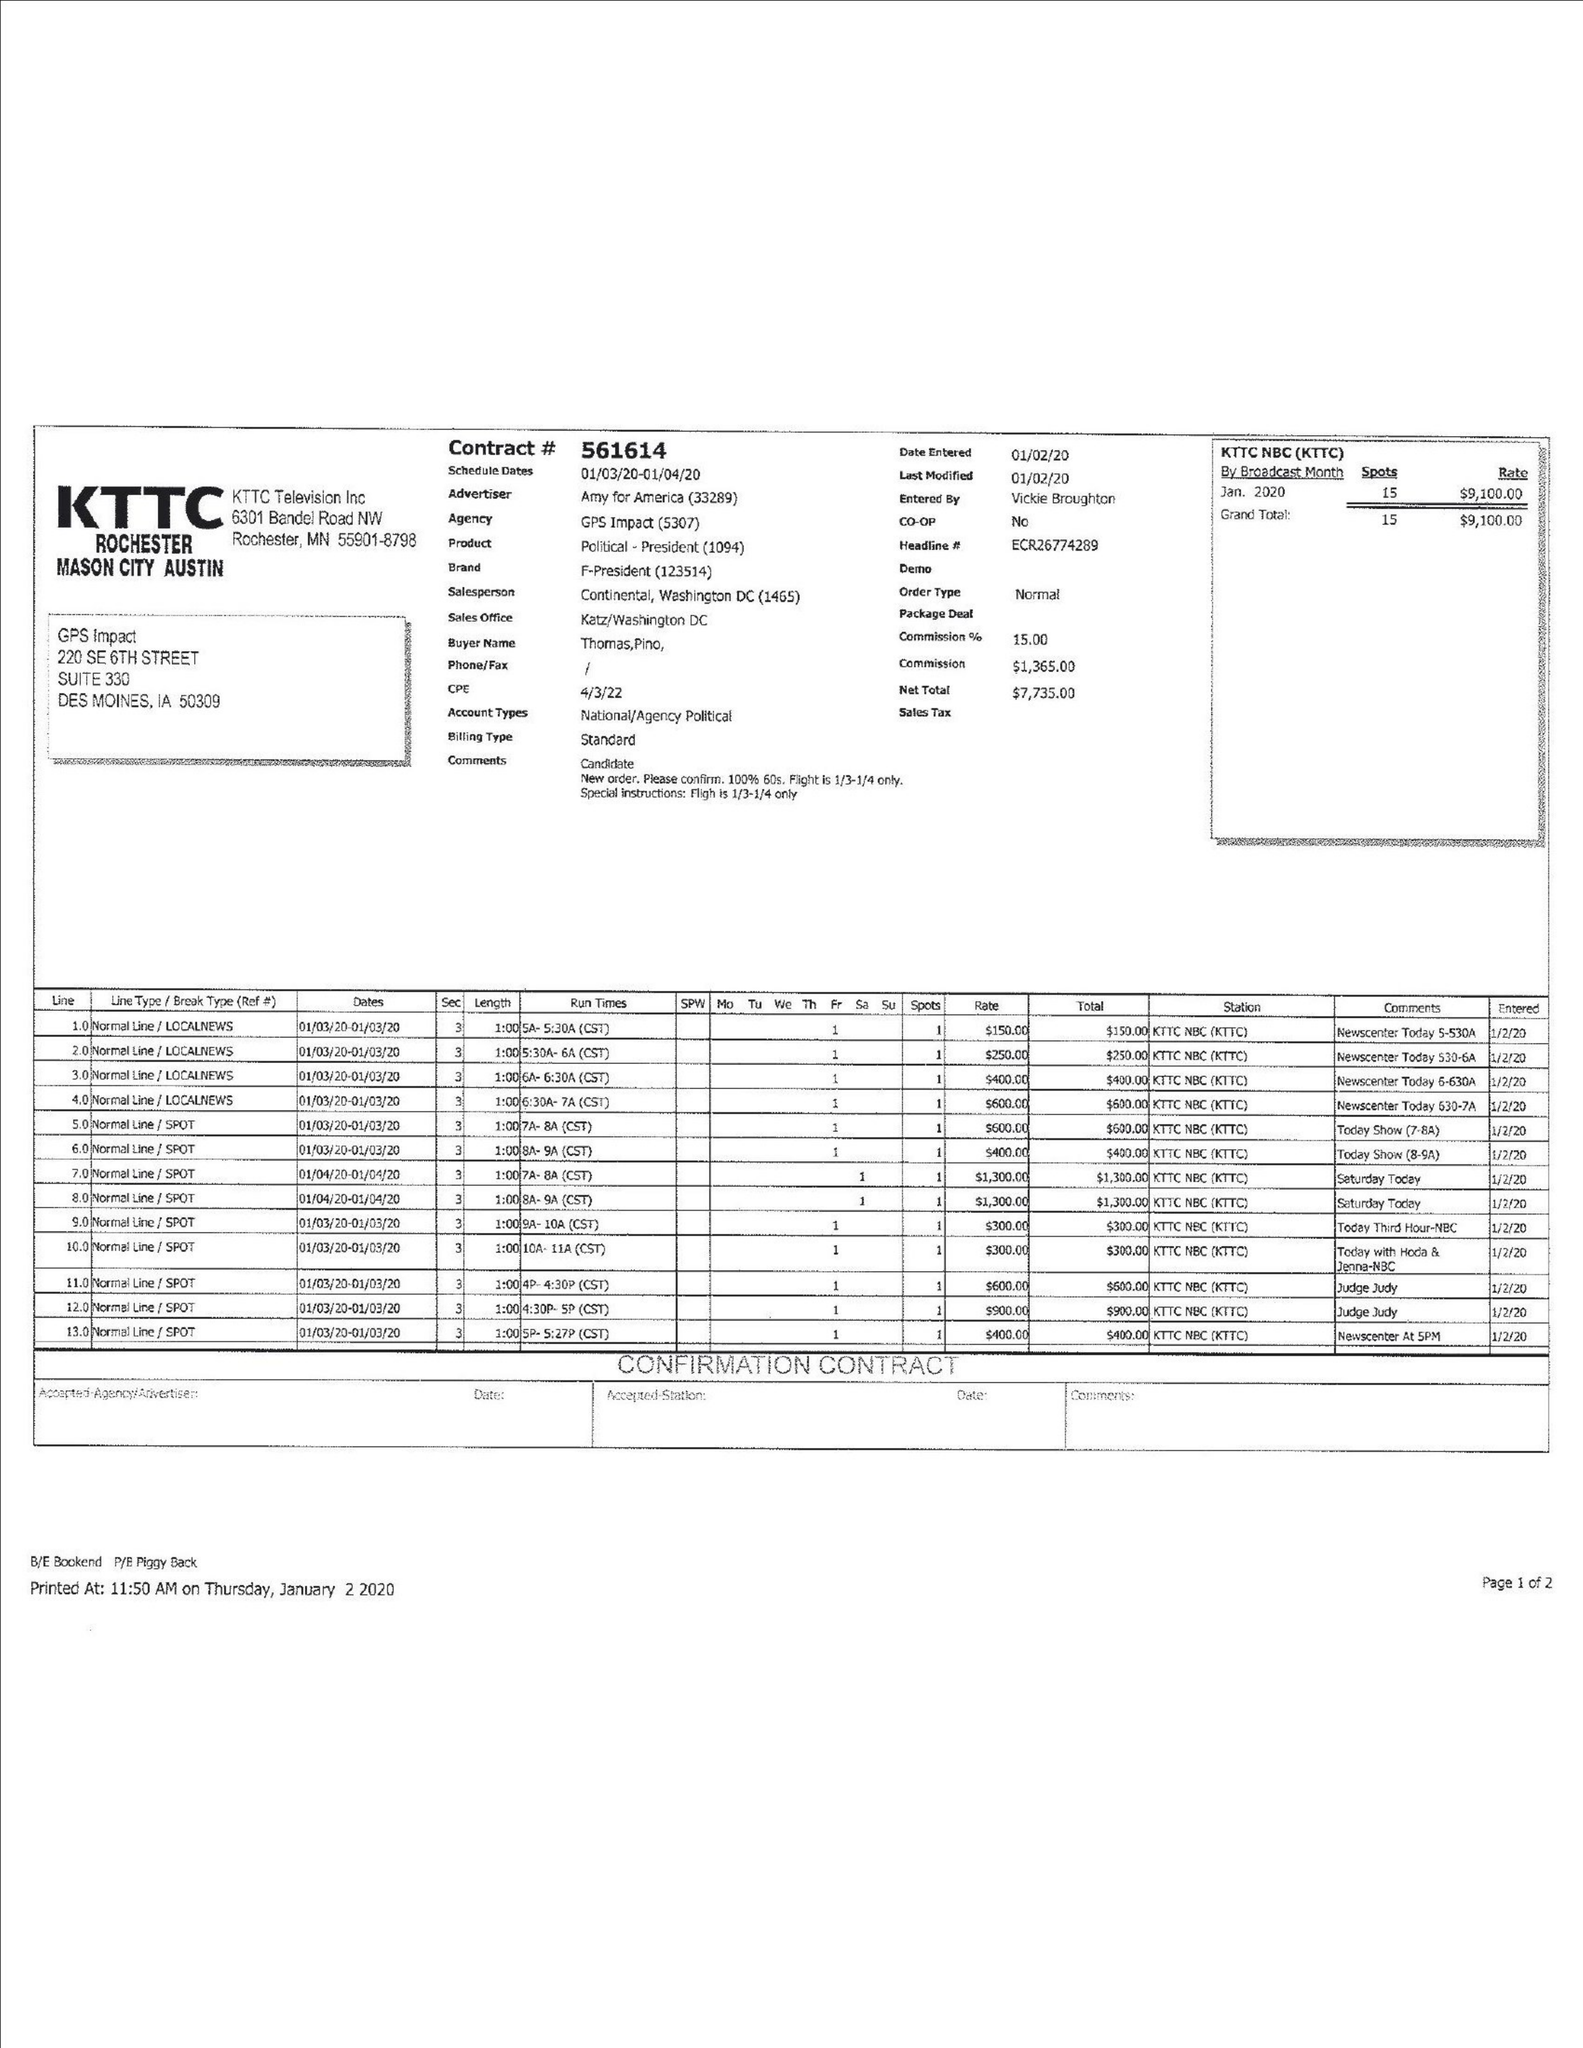What is the value for the contract_num?
Answer the question using a single word or phrase. 561614 